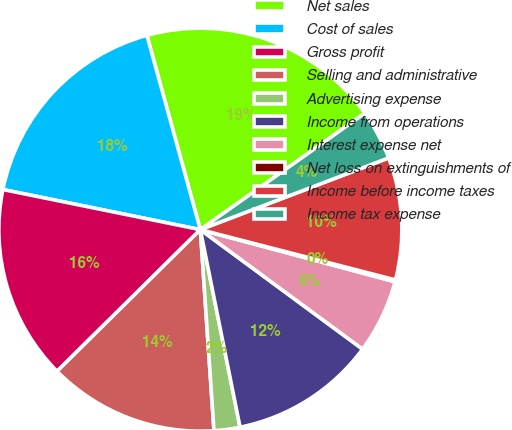Convert chart. <chart><loc_0><loc_0><loc_500><loc_500><pie_chart><fcel>Net sales<fcel>Cost of sales<fcel>Gross profit<fcel>Selling and administrative<fcel>Advertising expense<fcel>Income from operations<fcel>Interest expense net<fcel>Net loss on extinguishments of<fcel>Income before income taxes<fcel>Income tax expense<nl><fcel>19.47%<fcel>17.54%<fcel>15.6%<fcel>13.67%<fcel>2.08%<fcel>11.74%<fcel>5.94%<fcel>0.15%<fcel>9.81%<fcel>4.01%<nl></chart> 